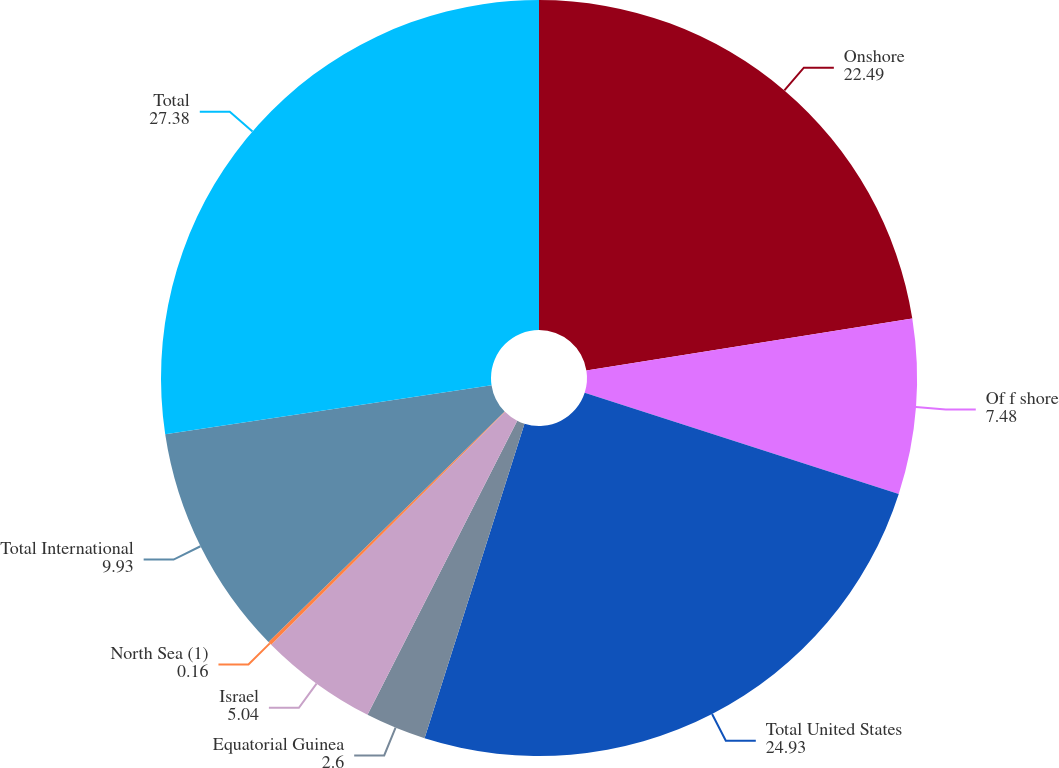Convert chart. <chart><loc_0><loc_0><loc_500><loc_500><pie_chart><fcel>Onshore<fcel>Of f shore<fcel>Total United States<fcel>Equatorial Guinea<fcel>Israel<fcel>North Sea (1)<fcel>Total International<fcel>Total<nl><fcel>22.49%<fcel>7.48%<fcel>24.93%<fcel>2.6%<fcel>5.04%<fcel>0.16%<fcel>9.93%<fcel>27.38%<nl></chart> 